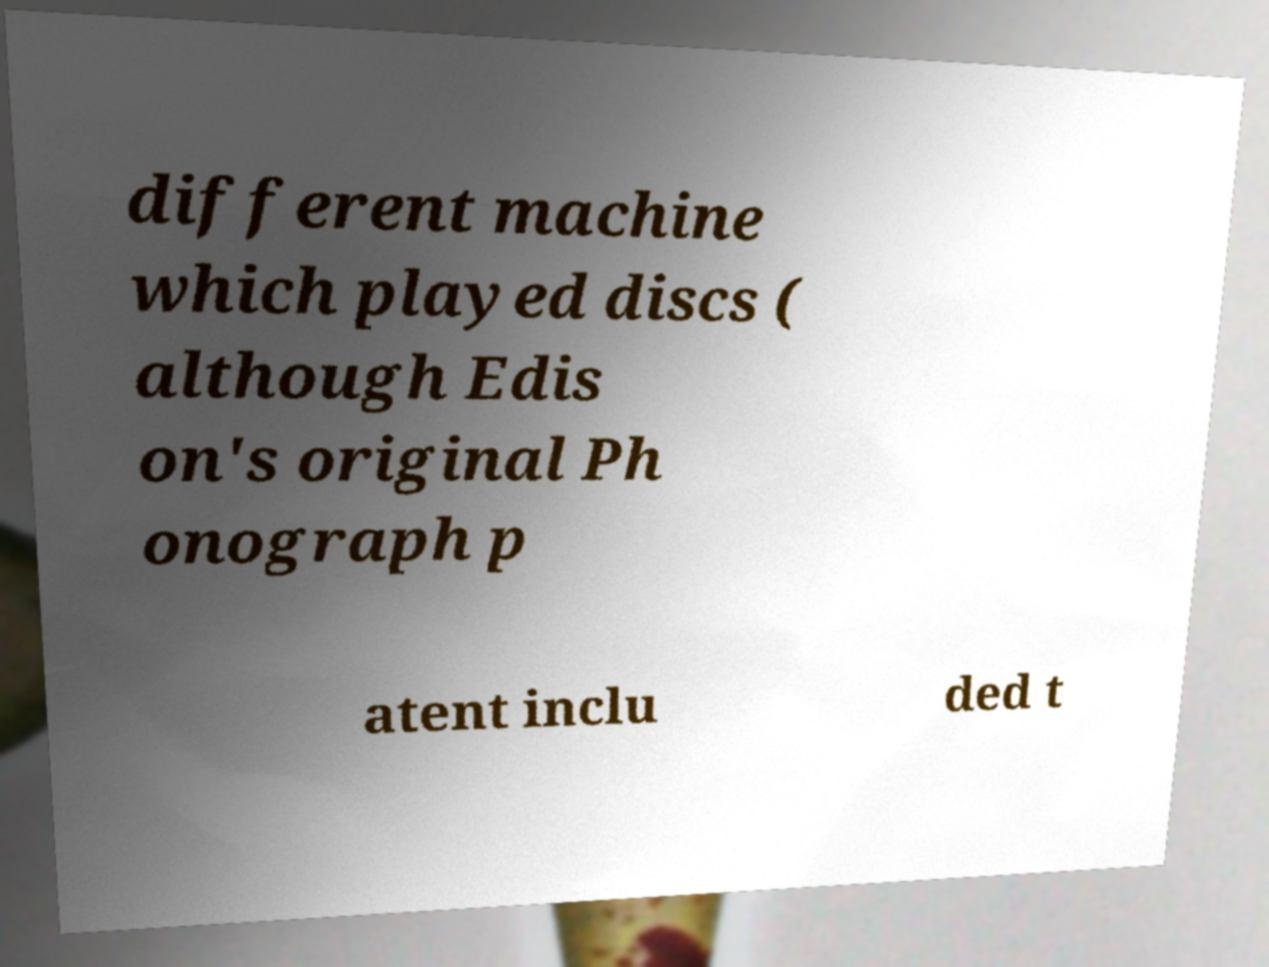What messages or text are displayed in this image? I need them in a readable, typed format. different machine which played discs ( although Edis on's original Ph onograph p atent inclu ded t 